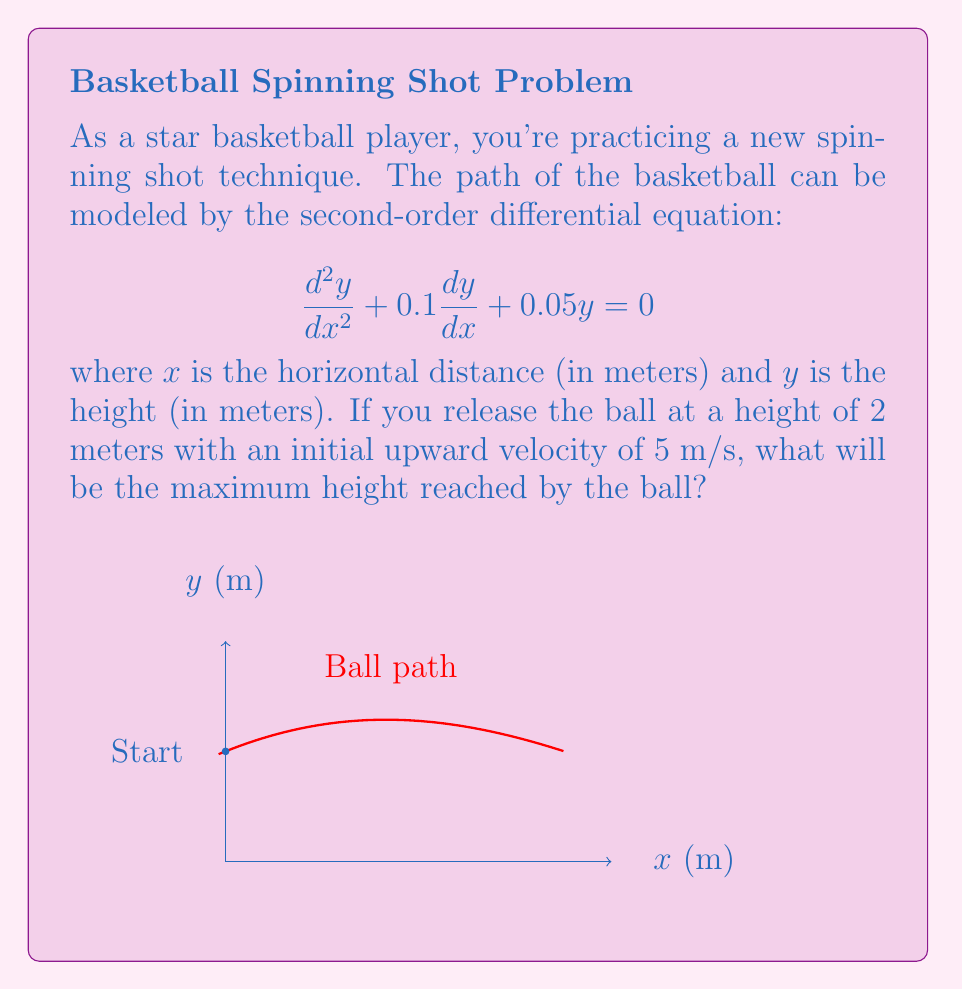Solve this math problem. Let's approach this step-by-step:

1) The general solution to this second-order linear differential equation is:

   $$y(x) = e^{-ax}(C_1 \cos(\omega x) + C_2 \sin(\omega x))$$

   where $a = 0.05$ and $\omega = \sqrt{0.05 - a^2} \approx 0.2165$

2) We need to find $C_1$ and $C_2$ using the initial conditions:
   - $y(0) = 2$ (initial height)
   - $y'(0) = 5$ (initial velocity)

3) From $y(0) = 2$, we get:
   $$2 = C_1$$

4) Taking the derivative of $y(x)$:
   $$y'(x) = -ae^{-ax}(C_1 \cos(\omega x) + C_2 \sin(\omega x)) + e^{-ax}(-C_1 \omega \sin(\omega x) + C_2 \omega \cos(\omega x))$$

5) At $x=0$, $y'(0) = 5$:
   $$5 = -a \cdot 2 + \omega C_2$$
   $$C_2 = \frac{5 + 0.1}{0.2165} \approx 23.5566$$

6) Now we have the complete equation:
   $$y(x) = e^{-0.05x}(2 \cos(0.2165x) + 23.5566 \sin(0.2165x))$$

7) To find the maximum height, we need to find where $y'(x) = 0$:
   $$y'(x) = e^{-0.05x}(-0.1 \cos(0.2165x) - 0.433 \sin(0.2165x) - 0.433 \cos(0.2165x) + 5.1 \sin(0.2165x))$$

8) Solving $y'(x) = 0$ numerically gives $x \approx 3.6246$

9) Plugging this back into $y(x)$:
   $$y(3.6246) \approx 3.1622$$

Therefore, the maximum height reached by the ball is approximately 3.16 meters.
Answer: 3.16 meters 